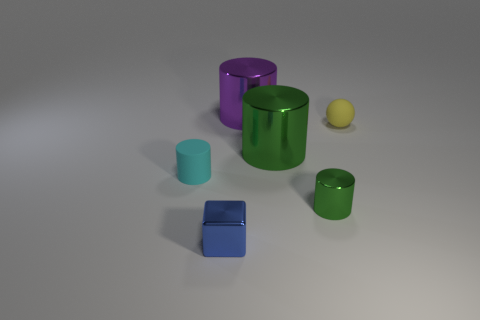There is another metal cylinder that is the same color as the small metallic cylinder; what is its size?
Make the answer very short. Large. There is a small matte object in front of the ball; is its shape the same as the object in front of the small green shiny cylinder?
Give a very brief answer. No. Is the number of small cyan things to the right of the tiny cyan object the same as the number of gray metal cylinders?
Keep it short and to the point. Yes. What is the material of the tiny cyan object that is the same shape as the big purple metal object?
Make the answer very short. Rubber. The tiny rubber thing to the right of the rubber object left of the tiny yellow rubber sphere is what shape?
Your answer should be compact. Sphere. Does the green cylinder that is behind the cyan rubber cylinder have the same material as the tiny green object?
Make the answer very short. Yes. Are there an equal number of green things that are left of the purple metallic object and small cyan matte cylinders that are behind the tiny yellow ball?
Your response must be concise. Yes. What is the material of the other cylinder that is the same color as the tiny shiny cylinder?
Offer a very short reply. Metal. There is a large object behind the small yellow ball; what number of tiny objects are to the left of it?
Your answer should be very brief. 2. Does the small cylinder right of the blue object have the same color as the large metal cylinder on the right side of the purple object?
Your response must be concise. Yes. 